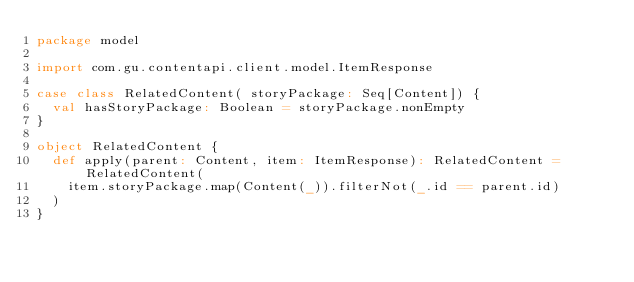<code> <loc_0><loc_0><loc_500><loc_500><_Scala_>package model

import com.gu.contentapi.client.model.ItemResponse

case class RelatedContent( storyPackage: Seq[Content]) {
  val hasStoryPackage: Boolean = storyPackage.nonEmpty
}

object RelatedContent {
  def apply(parent: Content, item: ItemResponse): RelatedContent = RelatedContent(
    item.storyPackage.map(Content(_)).filterNot(_.id == parent.id)
  )
}
</code> 